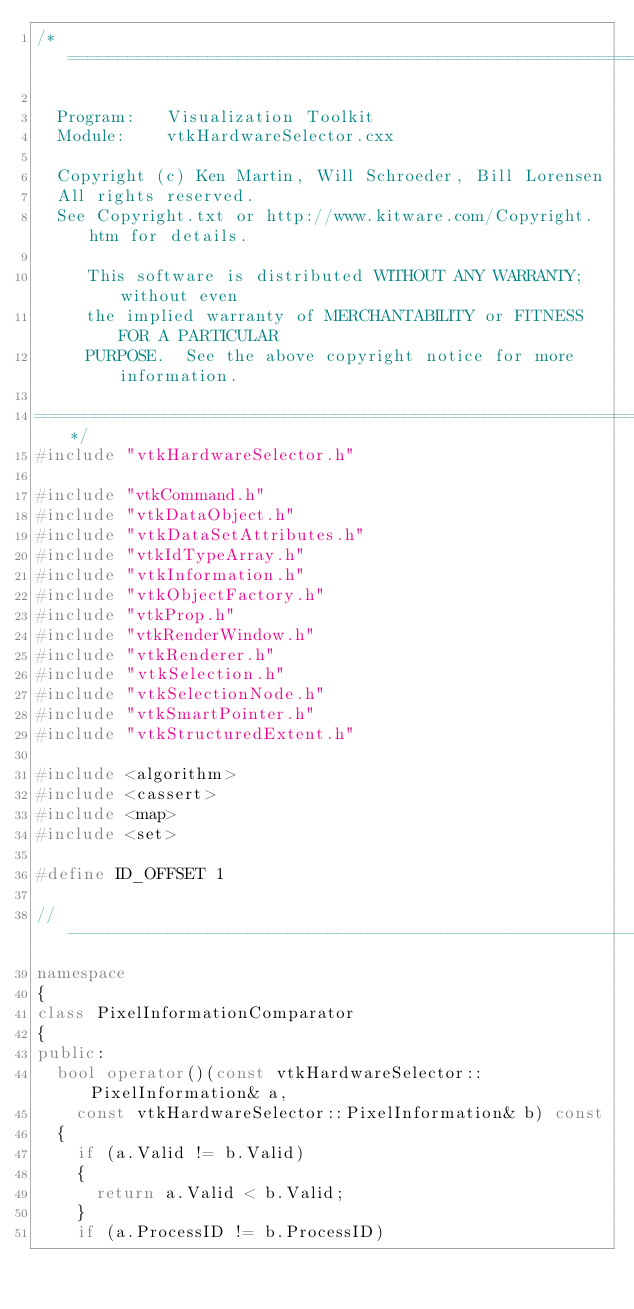Convert code to text. <code><loc_0><loc_0><loc_500><loc_500><_C++_>/*=========================================================================

  Program:   Visualization Toolkit
  Module:    vtkHardwareSelector.cxx

  Copyright (c) Ken Martin, Will Schroeder, Bill Lorensen
  All rights reserved.
  See Copyright.txt or http://www.kitware.com/Copyright.htm for details.

     This software is distributed WITHOUT ANY WARRANTY; without even
     the implied warranty of MERCHANTABILITY or FITNESS FOR A PARTICULAR
     PURPOSE.  See the above copyright notice for more information.

=========================================================================*/
#include "vtkHardwareSelector.h"

#include "vtkCommand.h"
#include "vtkDataObject.h"
#include "vtkDataSetAttributes.h"
#include "vtkIdTypeArray.h"
#include "vtkInformation.h"
#include "vtkObjectFactory.h"
#include "vtkProp.h"
#include "vtkRenderWindow.h"
#include "vtkRenderer.h"
#include "vtkSelection.h"
#include "vtkSelectionNode.h"
#include "vtkSmartPointer.h"
#include "vtkStructuredExtent.h"

#include <algorithm>
#include <cassert>
#include <map>
#include <set>

#define ID_OFFSET 1

//------------------------------------------------------------------------------
namespace
{
class PixelInformationComparator
{
public:
  bool operator()(const vtkHardwareSelector::PixelInformation& a,
    const vtkHardwareSelector::PixelInformation& b) const
  {
    if (a.Valid != b.Valid)
    {
      return a.Valid < b.Valid;
    }
    if (a.ProcessID != b.ProcessID)</code> 